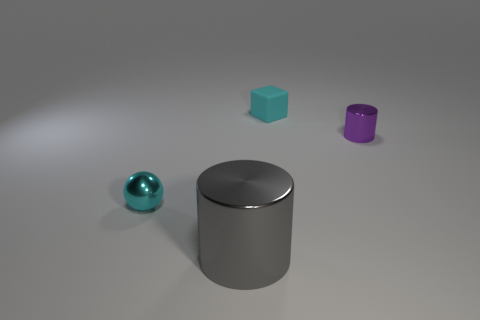Add 3 tiny yellow balls. How many objects exist? 7 Subtract all blocks. How many objects are left? 3 Subtract all tiny cyan rubber objects. Subtract all tiny purple metal things. How many objects are left? 2 Add 2 small cyan matte cubes. How many small cyan matte cubes are left? 3 Add 1 gray matte cylinders. How many gray matte cylinders exist? 1 Subtract 0 green cylinders. How many objects are left? 4 